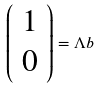<formula> <loc_0><loc_0><loc_500><loc_500>\left ( \begin{array} { c } 1 \\ 0 \end{array} \right ) = \Lambda b</formula> 